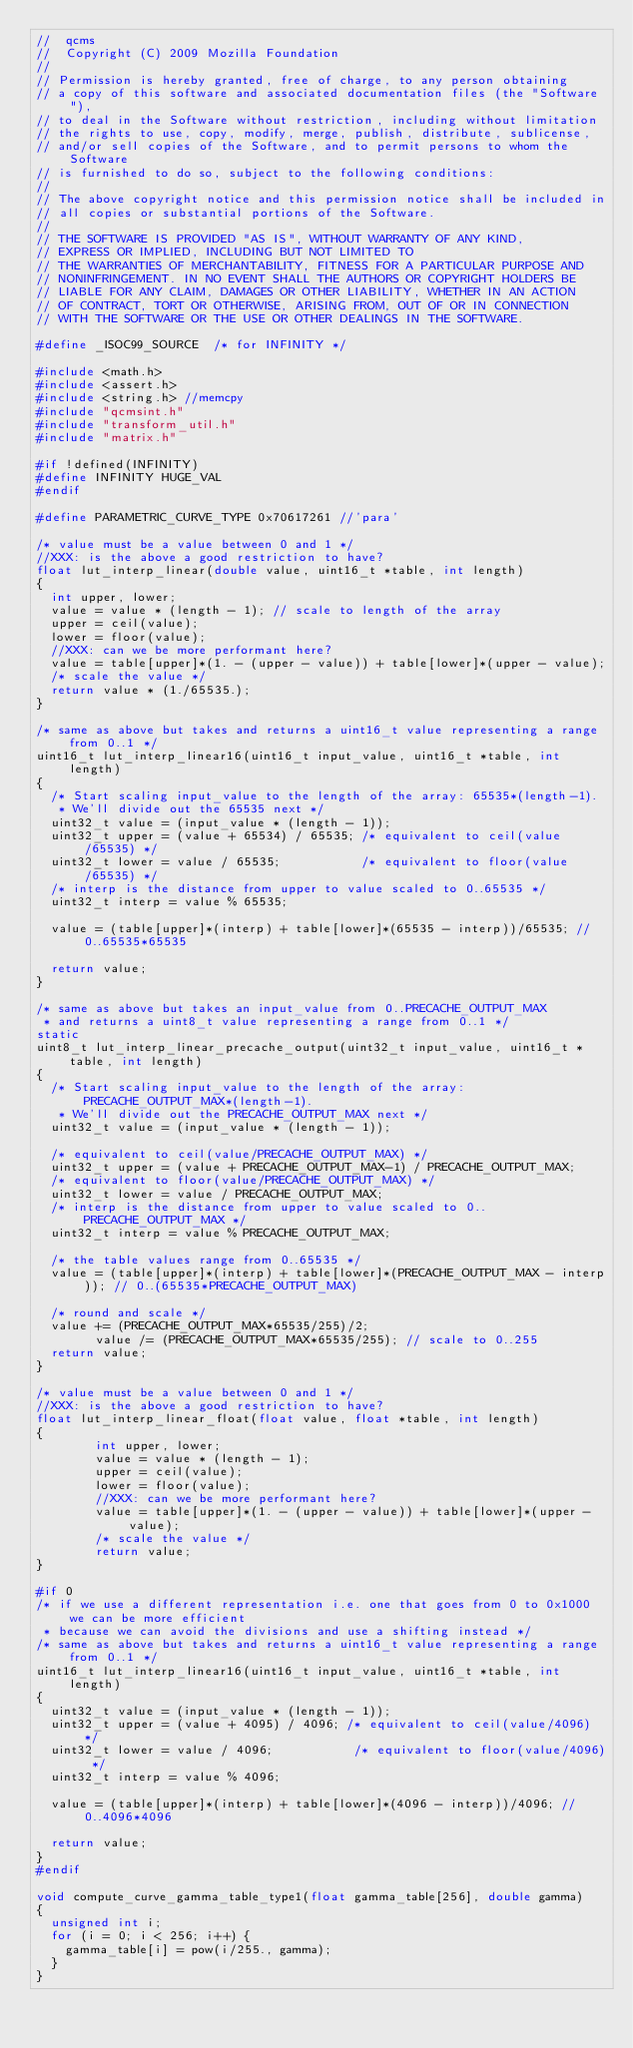<code> <loc_0><loc_0><loc_500><loc_500><_C_>//  qcms
//  Copyright (C) 2009 Mozilla Foundation
//
// Permission is hereby granted, free of charge, to any person obtaining
// a copy of this software and associated documentation files (the "Software"),
// to deal in the Software without restriction, including without limitation
// the rights to use, copy, modify, merge, publish, distribute, sublicense,
// and/or sell copies of the Software, and to permit persons to whom the Software
// is furnished to do so, subject to the following conditions:
//
// The above copyright notice and this permission notice shall be included in
// all copies or substantial portions of the Software.
//
// THE SOFTWARE IS PROVIDED "AS IS", WITHOUT WARRANTY OF ANY KIND,
// EXPRESS OR IMPLIED, INCLUDING BUT NOT LIMITED TO
// THE WARRANTIES OF MERCHANTABILITY, FITNESS FOR A PARTICULAR PURPOSE AND
// NONINFRINGEMENT. IN NO EVENT SHALL THE AUTHORS OR COPYRIGHT HOLDERS BE
// LIABLE FOR ANY CLAIM, DAMAGES OR OTHER LIABILITY, WHETHER IN AN ACTION
// OF CONTRACT, TORT OR OTHERWISE, ARISING FROM, OUT OF OR IN CONNECTION
// WITH THE SOFTWARE OR THE USE OR OTHER DEALINGS IN THE SOFTWARE.

#define _ISOC99_SOURCE  /* for INFINITY */

#include <math.h>
#include <assert.h>
#include <string.h> //memcpy
#include "qcmsint.h"
#include "transform_util.h"
#include "matrix.h"

#if !defined(INFINITY)
#define INFINITY HUGE_VAL
#endif

#define PARAMETRIC_CURVE_TYPE 0x70617261 //'para'

/* value must be a value between 0 and 1 */
//XXX: is the above a good restriction to have?
float lut_interp_linear(double value, uint16_t *table, int length)
{
	int upper, lower;
	value = value * (length - 1); // scale to length of the array
	upper = ceil(value);
	lower = floor(value);
	//XXX: can we be more performant here?
	value = table[upper]*(1. - (upper - value)) + table[lower]*(upper - value);
	/* scale the value */
	return value * (1./65535.);
}

/* same as above but takes and returns a uint16_t value representing a range from 0..1 */
uint16_t lut_interp_linear16(uint16_t input_value, uint16_t *table, int length)
{
	/* Start scaling input_value to the length of the array: 65535*(length-1).
	 * We'll divide out the 65535 next */
	uint32_t value = (input_value * (length - 1));
	uint32_t upper = (value + 65534) / 65535; /* equivalent to ceil(value/65535) */
	uint32_t lower = value / 65535;           /* equivalent to floor(value/65535) */
	/* interp is the distance from upper to value scaled to 0..65535 */
	uint32_t interp = value % 65535;

	value = (table[upper]*(interp) + table[lower]*(65535 - interp))/65535; // 0..65535*65535

	return value;
}

/* same as above but takes an input_value from 0..PRECACHE_OUTPUT_MAX
 * and returns a uint8_t value representing a range from 0..1 */
static
uint8_t lut_interp_linear_precache_output(uint32_t input_value, uint16_t *table, int length)
{
	/* Start scaling input_value to the length of the array: PRECACHE_OUTPUT_MAX*(length-1).
	 * We'll divide out the PRECACHE_OUTPUT_MAX next */
	uint32_t value = (input_value * (length - 1));

	/* equivalent to ceil(value/PRECACHE_OUTPUT_MAX) */
	uint32_t upper = (value + PRECACHE_OUTPUT_MAX-1) / PRECACHE_OUTPUT_MAX;
	/* equivalent to floor(value/PRECACHE_OUTPUT_MAX) */
	uint32_t lower = value / PRECACHE_OUTPUT_MAX;
	/* interp is the distance from upper to value scaled to 0..PRECACHE_OUTPUT_MAX */
	uint32_t interp = value % PRECACHE_OUTPUT_MAX;

	/* the table values range from 0..65535 */
	value = (table[upper]*(interp) + table[lower]*(PRECACHE_OUTPUT_MAX - interp)); // 0..(65535*PRECACHE_OUTPUT_MAX)

	/* round and scale */
	value += (PRECACHE_OUTPUT_MAX*65535/255)/2;
        value /= (PRECACHE_OUTPUT_MAX*65535/255); // scale to 0..255
	return value;
}

/* value must be a value between 0 and 1 */
//XXX: is the above a good restriction to have?
float lut_interp_linear_float(float value, float *table, int length)
{
        int upper, lower;
        value = value * (length - 1);
        upper = ceil(value);
        lower = floor(value);
        //XXX: can we be more performant here?
        value = table[upper]*(1. - (upper - value)) + table[lower]*(upper - value);
        /* scale the value */
        return value;
}

#if 0
/* if we use a different representation i.e. one that goes from 0 to 0x1000 we can be more efficient
 * because we can avoid the divisions and use a shifting instead */
/* same as above but takes and returns a uint16_t value representing a range from 0..1 */
uint16_t lut_interp_linear16(uint16_t input_value, uint16_t *table, int length)
{
	uint32_t value = (input_value * (length - 1));
	uint32_t upper = (value + 4095) / 4096; /* equivalent to ceil(value/4096) */
	uint32_t lower = value / 4096;           /* equivalent to floor(value/4096) */
	uint32_t interp = value % 4096;

	value = (table[upper]*(interp) + table[lower]*(4096 - interp))/4096; // 0..4096*4096

	return value;
}
#endif

void compute_curve_gamma_table_type1(float gamma_table[256], double gamma)
{
	unsigned int i;
	for (i = 0; i < 256; i++) {
		gamma_table[i] = pow(i/255., gamma);
	}
}
</code> 